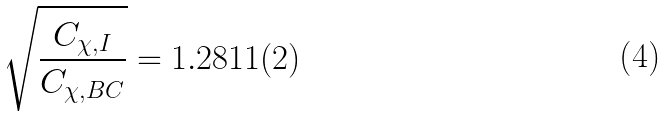<formula> <loc_0><loc_0><loc_500><loc_500>\sqrt { \frac { C _ { \chi , I } } { C _ { \chi , B C } } } = 1 . 2 8 1 1 ( 2 )</formula> 